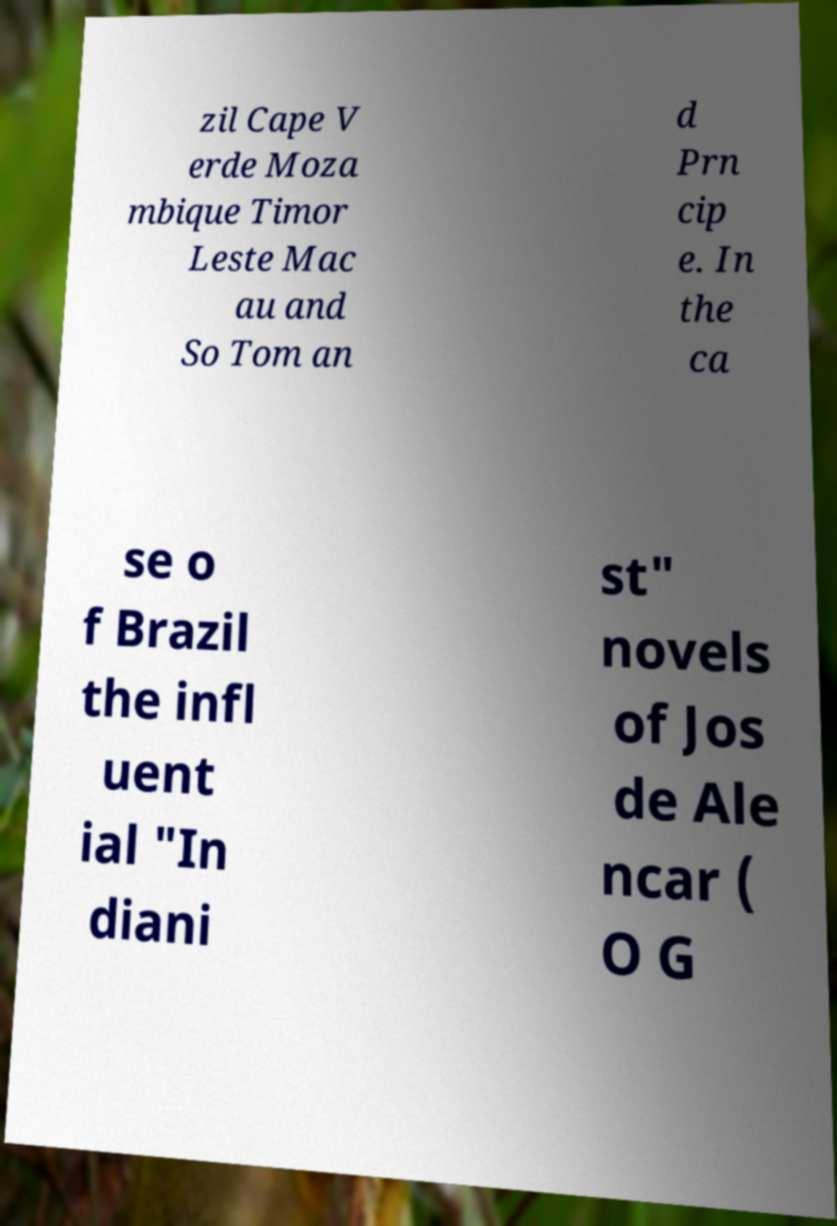I need the written content from this picture converted into text. Can you do that? zil Cape V erde Moza mbique Timor Leste Mac au and So Tom an d Prn cip e. In the ca se o f Brazil the infl uent ial "In diani st" novels of Jos de Ale ncar ( O G 